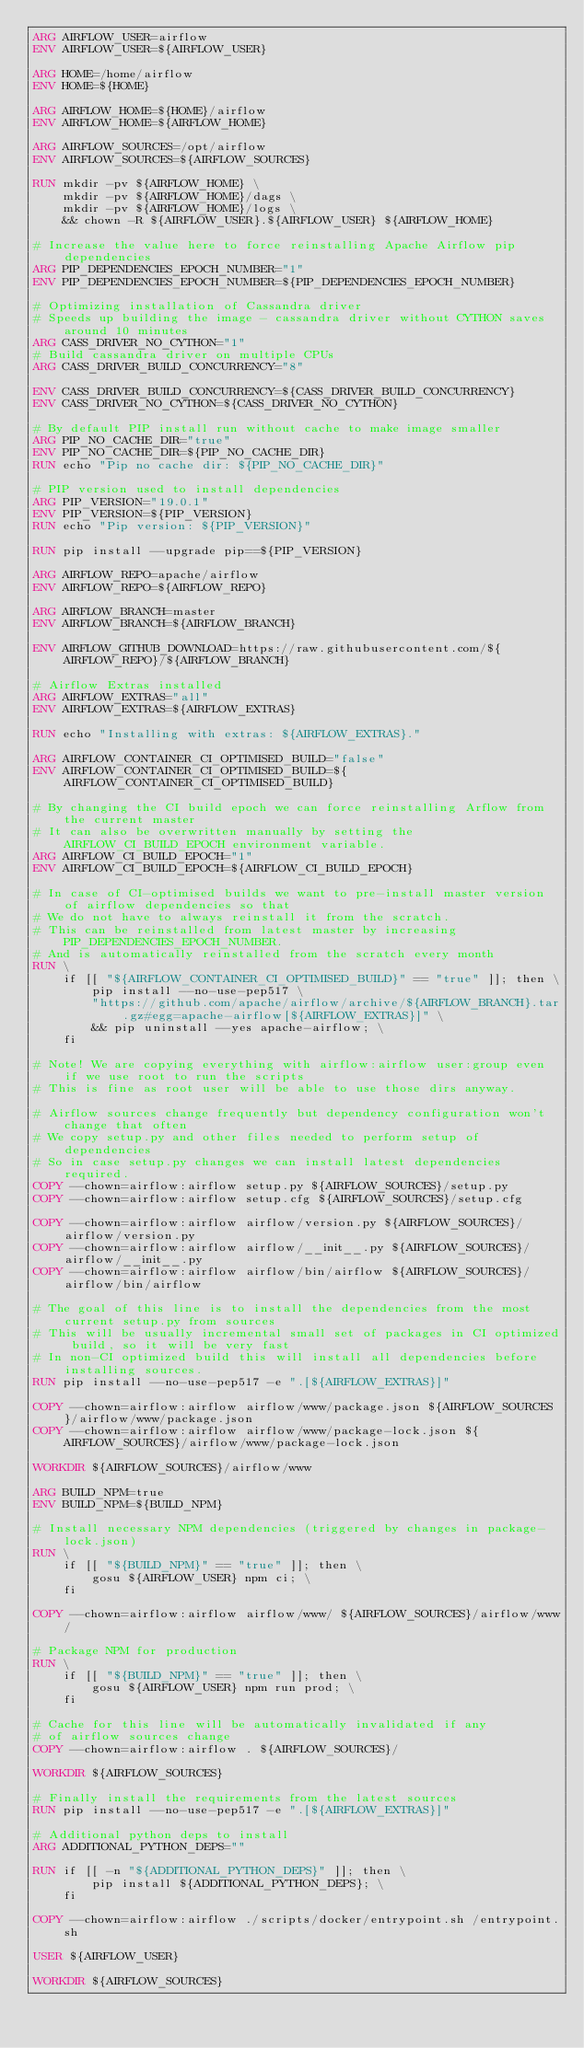<code> <loc_0><loc_0><loc_500><loc_500><_Dockerfile_>ARG AIRFLOW_USER=airflow
ENV AIRFLOW_USER=${AIRFLOW_USER}

ARG HOME=/home/airflow
ENV HOME=${HOME}

ARG AIRFLOW_HOME=${HOME}/airflow
ENV AIRFLOW_HOME=${AIRFLOW_HOME}

ARG AIRFLOW_SOURCES=/opt/airflow
ENV AIRFLOW_SOURCES=${AIRFLOW_SOURCES}

RUN mkdir -pv ${AIRFLOW_HOME} \
    mkdir -pv ${AIRFLOW_HOME}/dags \
    mkdir -pv ${AIRFLOW_HOME}/logs \
    && chown -R ${AIRFLOW_USER}.${AIRFLOW_USER} ${AIRFLOW_HOME}

# Increase the value here to force reinstalling Apache Airflow pip dependencies
ARG PIP_DEPENDENCIES_EPOCH_NUMBER="1"
ENV PIP_DEPENDENCIES_EPOCH_NUMBER=${PIP_DEPENDENCIES_EPOCH_NUMBER}

# Optimizing installation of Cassandra driver
# Speeds up building the image - cassandra driver without CYTHON saves around 10 minutes
ARG CASS_DRIVER_NO_CYTHON="1"
# Build cassandra driver on multiple CPUs
ARG CASS_DRIVER_BUILD_CONCURRENCY="8"

ENV CASS_DRIVER_BUILD_CONCURRENCY=${CASS_DRIVER_BUILD_CONCURRENCY}
ENV CASS_DRIVER_NO_CYTHON=${CASS_DRIVER_NO_CYTHON}

# By default PIP install run without cache to make image smaller
ARG PIP_NO_CACHE_DIR="true"
ENV PIP_NO_CACHE_DIR=${PIP_NO_CACHE_DIR}
RUN echo "Pip no cache dir: ${PIP_NO_CACHE_DIR}"

# PIP version used to install dependencies
ARG PIP_VERSION="19.0.1"
ENV PIP_VERSION=${PIP_VERSION}
RUN echo "Pip version: ${PIP_VERSION}"

RUN pip install --upgrade pip==${PIP_VERSION}

ARG AIRFLOW_REPO=apache/airflow
ENV AIRFLOW_REPO=${AIRFLOW_REPO}

ARG AIRFLOW_BRANCH=master
ENV AIRFLOW_BRANCH=${AIRFLOW_BRANCH}

ENV AIRFLOW_GITHUB_DOWNLOAD=https://raw.githubusercontent.com/${AIRFLOW_REPO}/${AIRFLOW_BRANCH}

# Airflow Extras installed
ARG AIRFLOW_EXTRAS="all"
ENV AIRFLOW_EXTRAS=${AIRFLOW_EXTRAS}

RUN echo "Installing with extras: ${AIRFLOW_EXTRAS}."

ARG AIRFLOW_CONTAINER_CI_OPTIMISED_BUILD="false"
ENV AIRFLOW_CONTAINER_CI_OPTIMISED_BUILD=${AIRFLOW_CONTAINER_CI_OPTIMISED_BUILD}

# By changing the CI build epoch we can force reinstalling Arflow from the current master
# It can also be overwritten manually by setting the AIRFLOW_CI_BUILD_EPOCH environment variable.
ARG AIRFLOW_CI_BUILD_EPOCH="1"
ENV AIRFLOW_CI_BUILD_EPOCH=${AIRFLOW_CI_BUILD_EPOCH}

# In case of CI-optimised builds we want to pre-install master version of airflow dependencies so that
# We do not have to always reinstall it from the scratch.
# This can be reinstalled from latest master by increasing PIP_DEPENDENCIES_EPOCH_NUMBER.
# And is automatically reinstalled from the scratch every month
RUN \
    if [[ "${AIRFLOW_CONTAINER_CI_OPTIMISED_BUILD}" == "true" ]]; then \
        pip install --no-use-pep517 \
        "https://github.com/apache/airflow/archive/${AIRFLOW_BRANCH}.tar.gz#egg=apache-airflow[${AIRFLOW_EXTRAS}]" \
        && pip uninstall --yes apache-airflow; \
    fi

# Note! We are copying everything with airflow:airflow user:group even if we use root to run the scripts
# This is fine as root user will be able to use those dirs anyway.

# Airflow sources change frequently but dependency configuration won't change that often
# We copy setup.py and other files needed to perform setup of dependencies
# So in case setup.py changes we can install latest dependencies required.
COPY --chown=airflow:airflow setup.py ${AIRFLOW_SOURCES}/setup.py
COPY --chown=airflow:airflow setup.cfg ${AIRFLOW_SOURCES}/setup.cfg

COPY --chown=airflow:airflow airflow/version.py ${AIRFLOW_SOURCES}/airflow/version.py
COPY --chown=airflow:airflow airflow/__init__.py ${AIRFLOW_SOURCES}/airflow/__init__.py
COPY --chown=airflow:airflow airflow/bin/airflow ${AIRFLOW_SOURCES}/airflow/bin/airflow

# The goal of this line is to install the dependencies from the most current setup.py from sources
# This will be usually incremental small set of packages in CI optimized build, so it will be very fast
# In non-CI optimized build this will install all dependencies before installing sources.
RUN pip install --no-use-pep517 -e ".[${AIRFLOW_EXTRAS}]"

COPY --chown=airflow:airflow airflow/www/package.json ${AIRFLOW_SOURCES}/airflow/www/package.json
COPY --chown=airflow:airflow airflow/www/package-lock.json ${AIRFLOW_SOURCES}/airflow/www/package-lock.json

WORKDIR ${AIRFLOW_SOURCES}/airflow/www

ARG BUILD_NPM=true
ENV BUILD_NPM=${BUILD_NPM}

# Install necessary NPM dependencies (triggered by changes in package-lock.json)
RUN \
    if [[ "${BUILD_NPM}" == "true" ]]; then \
        gosu ${AIRFLOW_USER} npm ci; \
    fi

COPY --chown=airflow:airflow airflow/www/ ${AIRFLOW_SOURCES}/airflow/www/

# Package NPM for production
RUN \
    if [[ "${BUILD_NPM}" == "true" ]]; then \
        gosu ${AIRFLOW_USER} npm run prod; \
    fi

# Cache for this line will be automatically invalidated if any
# of airflow sources change
COPY --chown=airflow:airflow . ${AIRFLOW_SOURCES}/

WORKDIR ${AIRFLOW_SOURCES}

# Finally install the requirements from the latest sources
RUN pip install --no-use-pep517 -e ".[${AIRFLOW_EXTRAS}]"

# Additional python deps to install
ARG ADDITIONAL_PYTHON_DEPS=""

RUN if [[ -n "${ADDITIONAL_PYTHON_DEPS}" ]]; then \
        pip install ${ADDITIONAL_PYTHON_DEPS}; \
    fi

COPY --chown=airflow:airflow ./scripts/docker/entrypoint.sh /entrypoint.sh

USER ${AIRFLOW_USER}

WORKDIR ${AIRFLOW_SOURCES}
</code> 